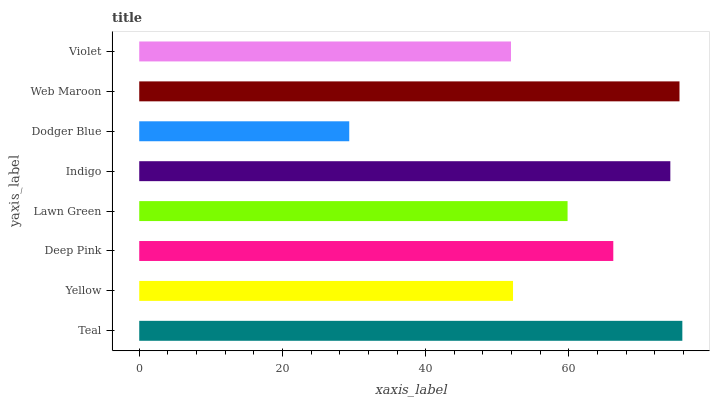Is Dodger Blue the minimum?
Answer yes or no. Yes. Is Teal the maximum?
Answer yes or no. Yes. Is Yellow the minimum?
Answer yes or no. No. Is Yellow the maximum?
Answer yes or no. No. Is Teal greater than Yellow?
Answer yes or no. Yes. Is Yellow less than Teal?
Answer yes or no. Yes. Is Yellow greater than Teal?
Answer yes or no. No. Is Teal less than Yellow?
Answer yes or no. No. Is Deep Pink the high median?
Answer yes or no. Yes. Is Lawn Green the low median?
Answer yes or no. Yes. Is Web Maroon the high median?
Answer yes or no. No. Is Indigo the low median?
Answer yes or no. No. 